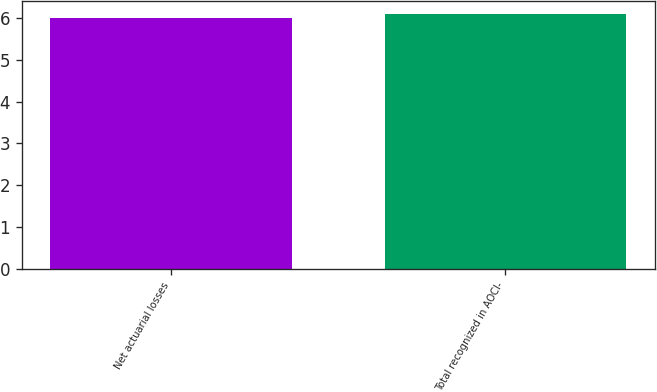<chart> <loc_0><loc_0><loc_500><loc_500><bar_chart><fcel>Net actuarial losses<fcel>Total recognized in AOCI-<nl><fcel>6<fcel>6.1<nl></chart> 